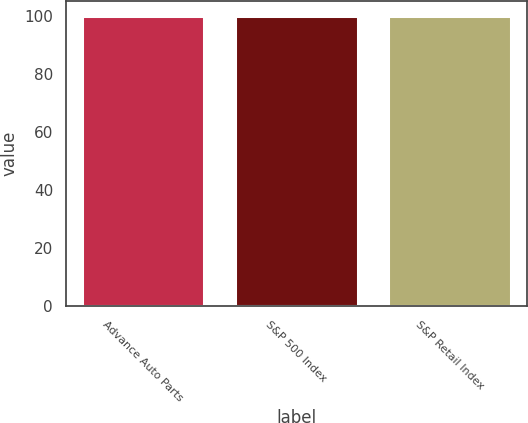Convert chart to OTSL. <chart><loc_0><loc_0><loc_500><loc_500><bar_chart><fcel>Advance Auto Parts<fcel>S&P 500 Index<fcel>S&P Retail Index<nl><fcel>100<fcel>100.1<fcel>100.2<nl></chart> 